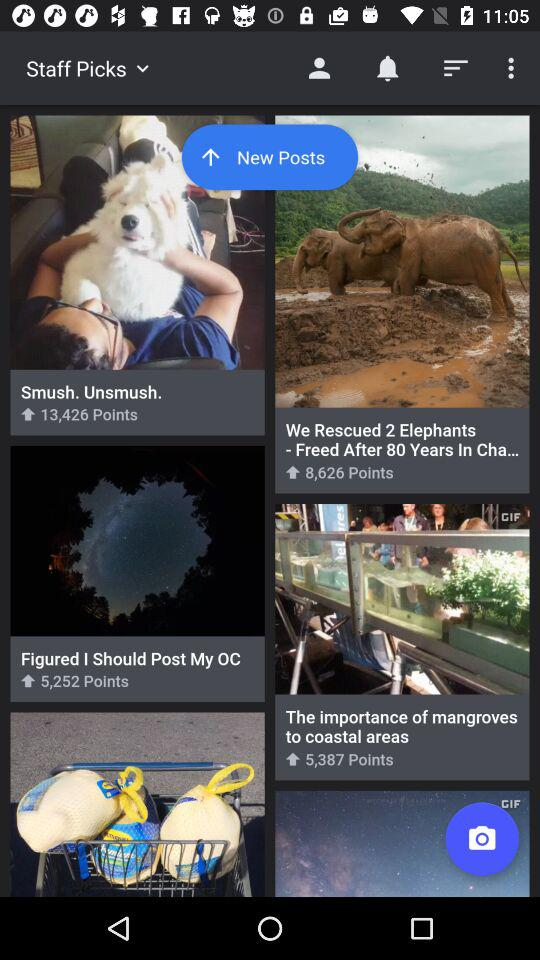Which pick has 5387 points? The pick with 5387 points is "The importance of mangroves to coastal areas". 